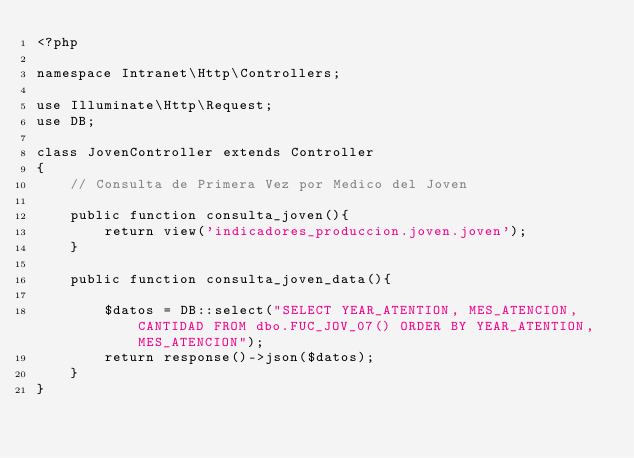<code> <loc_0><loc_0><loc_500><loc_500><_PHP_><?php

namespace Intranet\Http\Controllers;

use Illuminate\Http\Request;
use DB;

class JovenController extends Controller
{
    // Consulta de Primera Vez por Medico del Joven

    public function consulta_joven(){
        return view('indicadores_produccion.joven.joven');
    }

    public function consulta_joven_data(){

        $datos = DB::select("SELECT YEAR_ATENTION, MES_ATENCION, CANTIDAD FROM dbo.FUC_JOV_07() ORDER BY YEAR_ATENTION, MES_ATENCION");
        return response()->json($datos);
    }
}
</code> 